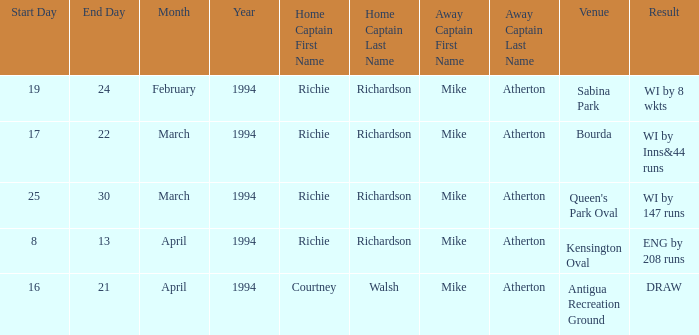Which home skipper has eng by 208 runs? Richie Richardson. 